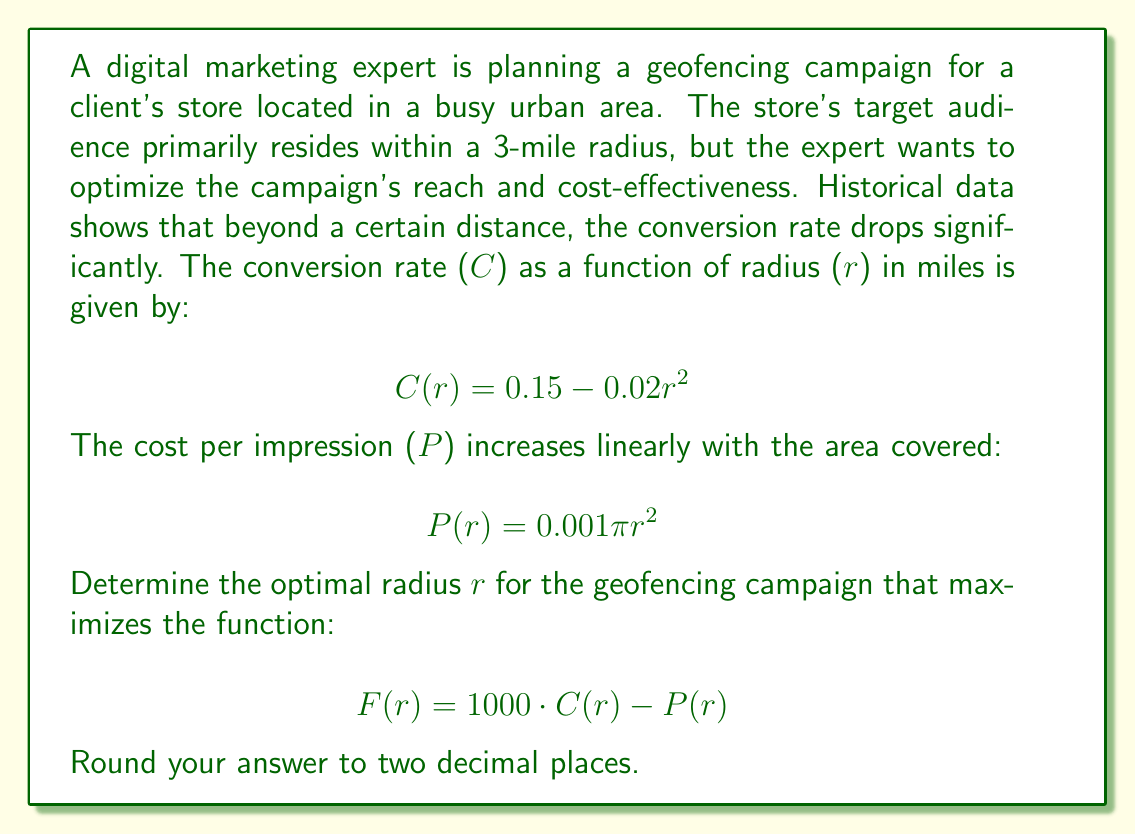Show me your answer to this math problem. To find the optimal radius, we need to maximize the function $F(r)$. Let's approach this step-by-step:

1) First, let's expand $F(r)$:
   $$F(r) = 1000 \cdot C(r) - P(r)$$
   $$F(r) = 1000 \cdot (0.15 - 0.02r^2) - 0.001\pi r^2$$
   $$F(r) = 150 - 20r^2 - 0.001\pi r^2$$

2) To find the maximum, we need to find where the derivative of $F(r)$ equals zero:
   $$F'(r) = -40r - 0.002\pi r$$
   $$F'(r) = -r(40 + 0.002\pi)$$

3) Set $F'(r) = 0$:
   $$-r(40 + 0.002\pi) = 0$$

4) Solve for $r$:
   $$r = 0$$ or $$40 + 0.002\pi = 0$$
   The second equation has no solution, so the only critical point is $r = 0$.

5) However, $r = 0$ doesn't make sense in this context. We need to consider the domain constraints. The question mentions a 3-mile radius, so let's consider $0 < r \leq 3$.

6) Since there are no critical points in the interior of our domain, the maximum must occur at one of the endpoints. Let's evaluate $F(r)$ at both ends:

   At $r = 0$: $F(0) = 150$
   At $r = 3$: $F(3) = 150 - 20(9) - 0.001\pi(9) = 150 - 180 - 0.02827\pi = -30.09$

7) Clearly, $F(0)$ is larger, but $r = 0$ isn't a practical solution. We need to find where $F(r)$ starts decreasing.

8) We can do this by solving $F(r) = 150$:
   $$150 - 20r^2 - 0.001\pi r^2 = 150$$
   $$-20r^2 - 0.001\pi r^2 = 0$$
   $$r^2(20 + 0.001\pi) = 0$$
   $$r^2 = 0$$ or $$r = 0$$

9) This tells us that $F(r)$ starts decreasing immediately after $r = 0$. Therefore, we want to choose the smallest practical radius for our campaign.

Given the nature of geofencing and digital marketing, a radius of 0.1 miles (about 160 meters) could be a reasonable minimum.
Answer: The optimal radius for the geofencing campaign is approximately 0.10 miles. 